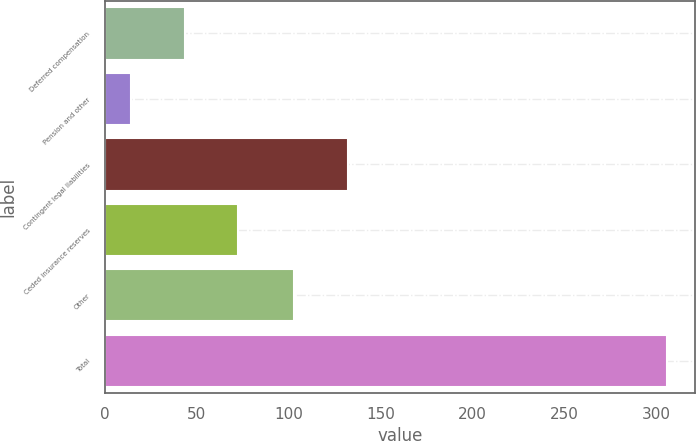Convert chart to OTSL. <chart><loc_0><loc_0><loc_500><loc_500><bar_chart><fcel>Deferred compensation<fcel>Pension and other<fcel>Contingent legal liabilities<fcel>Ceded insurance reserves<fcel>Other<fcel>Total<nl><fcel>43.51<fcel>14.4<fcel>132.21<fcel>72.62<fcel>103.1<fcel>305.5<nl></chart> 